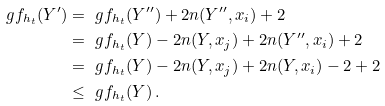<formula> <loc_0><loc_0><loc_500><loc_500>\ g f _ { h _ { t } } ( Y ^ { \prime } ) & = \ g f _ { h _ { t } } ( Y ^ { \prime \prime } ) + 2 n ( Y ^ { \prime \prime } , x _ { i } ) + 2 \\ & = \ g f _ { h _ { t } } ( Y ) - 2 n ( Y , x _ { j } ) + 2 n ( Y ^ { \prime \prime } , x _ { i } ) + 2 \\ & = \ g f _ { h _ { t } } ( Y ) - 2 n ( Y , x _ { j } ) + 2 n ( Y , x _ { i } ) - 2 + 2 \\ & \leq \ g f _ { h _ { t } } ( Y ) \, .</formula> 